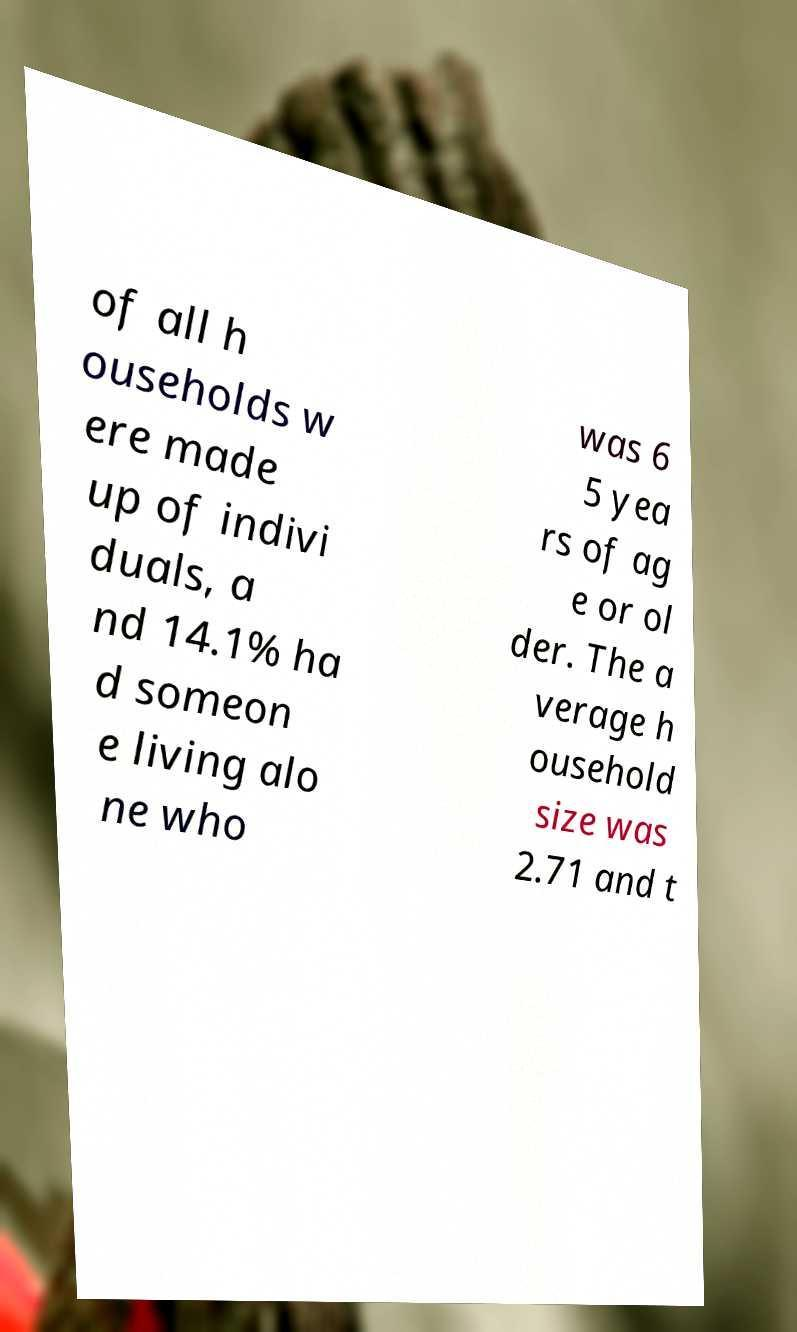Can you read and provide the text displayed in the image?This photo seems to have some interesting text. Can you extract and type it out for me? of all h ouseholds w ere made up of indivi duals, a nd 14.1% ha d someon e living alo ne who was 6 5 yea rs of ag e or ol der. The a verage h ousehold size was 2.71 and t 